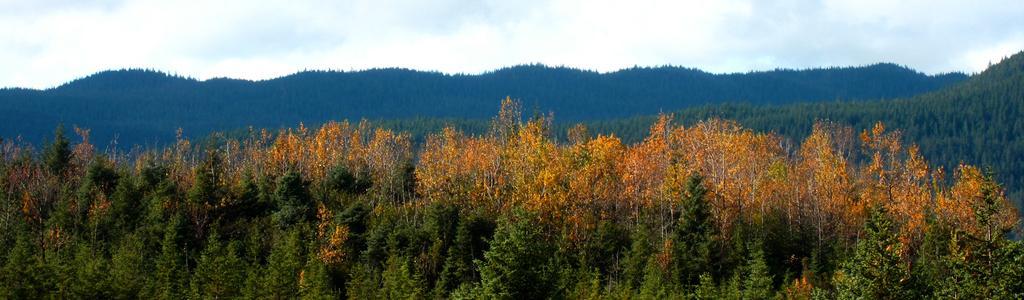How would you summarize this image in a sentence or two? In the picture we can see, full of plants, trees which are yellow in color and behind it also we can see full of trees, hills and sky with clouds. 